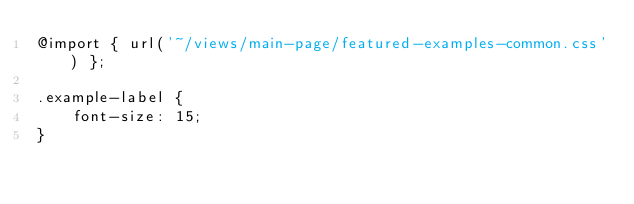<code> <loc_0><loc_0><loc_500><loc_500><_CSS_>@import { url('~/views/main-page/featured-examples-common.css') };

.example-label {
    font-size: 15;
}
</code> 